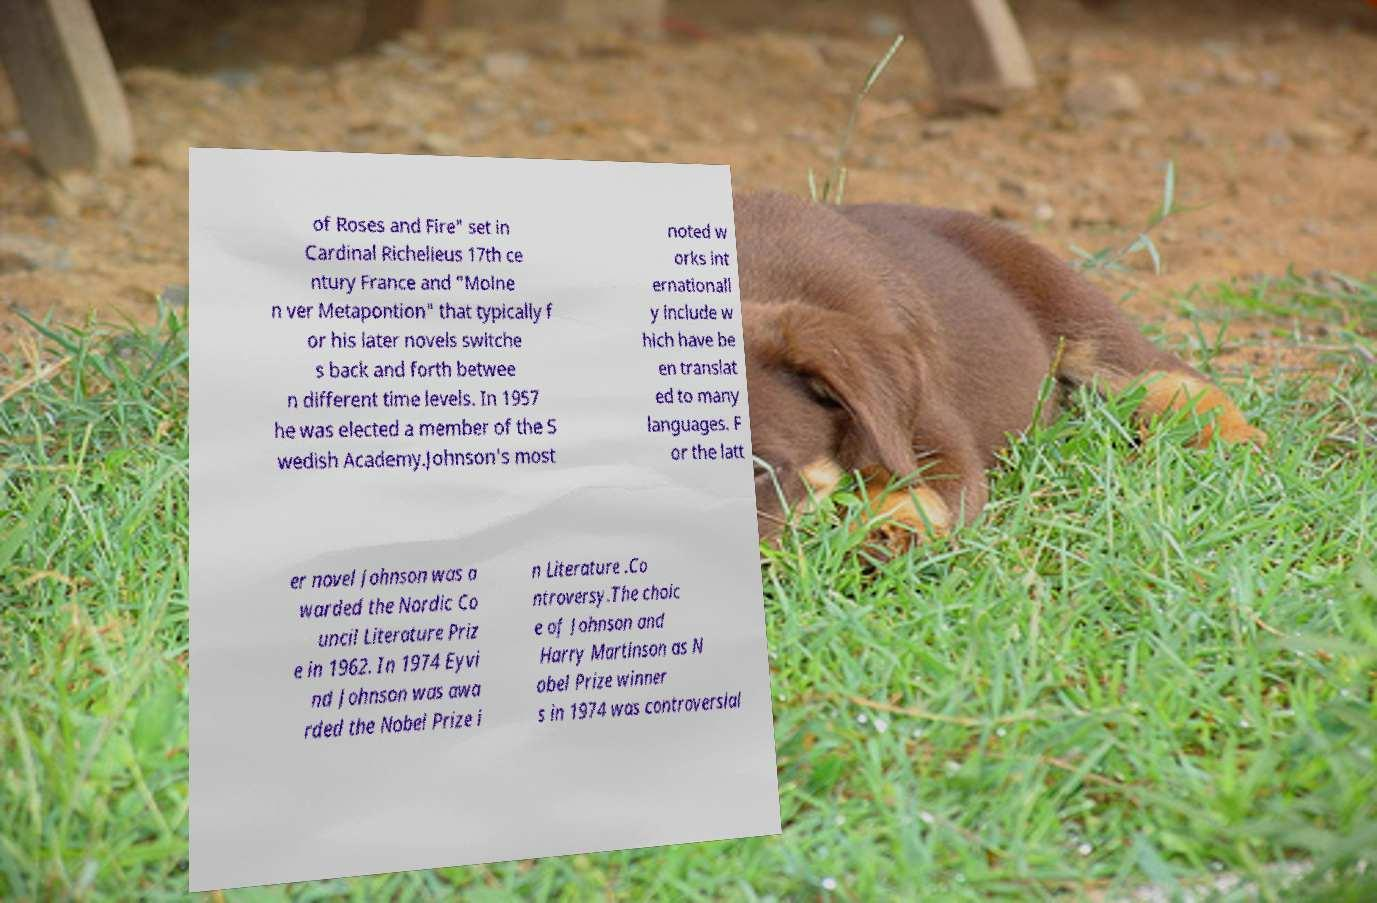I need the written content from this picture converted into text. Can you do that? of Roses and Fire" set in Cardinal Richelieus 17th ce ntury France and "Molne n ver Metapontion" that typically f or his later novels switche s back and forth betwee n different time levels. In 1957 he was elected a member of the S wedish Academy.Johnson's most noted w orks int ernationall y include w hich have be en translat ed to many languages. F or the latt er novel Johnson was a warded the Nordic Co uncil Literature Priz e in 1962. In 1974 Eyvi nd Johnson was awa rded the Nobel Prize i n Literature .Co ntroversy.The choic e of Johnson and Harry Martinson as N obel Prize winner s in 1974 was controversial 